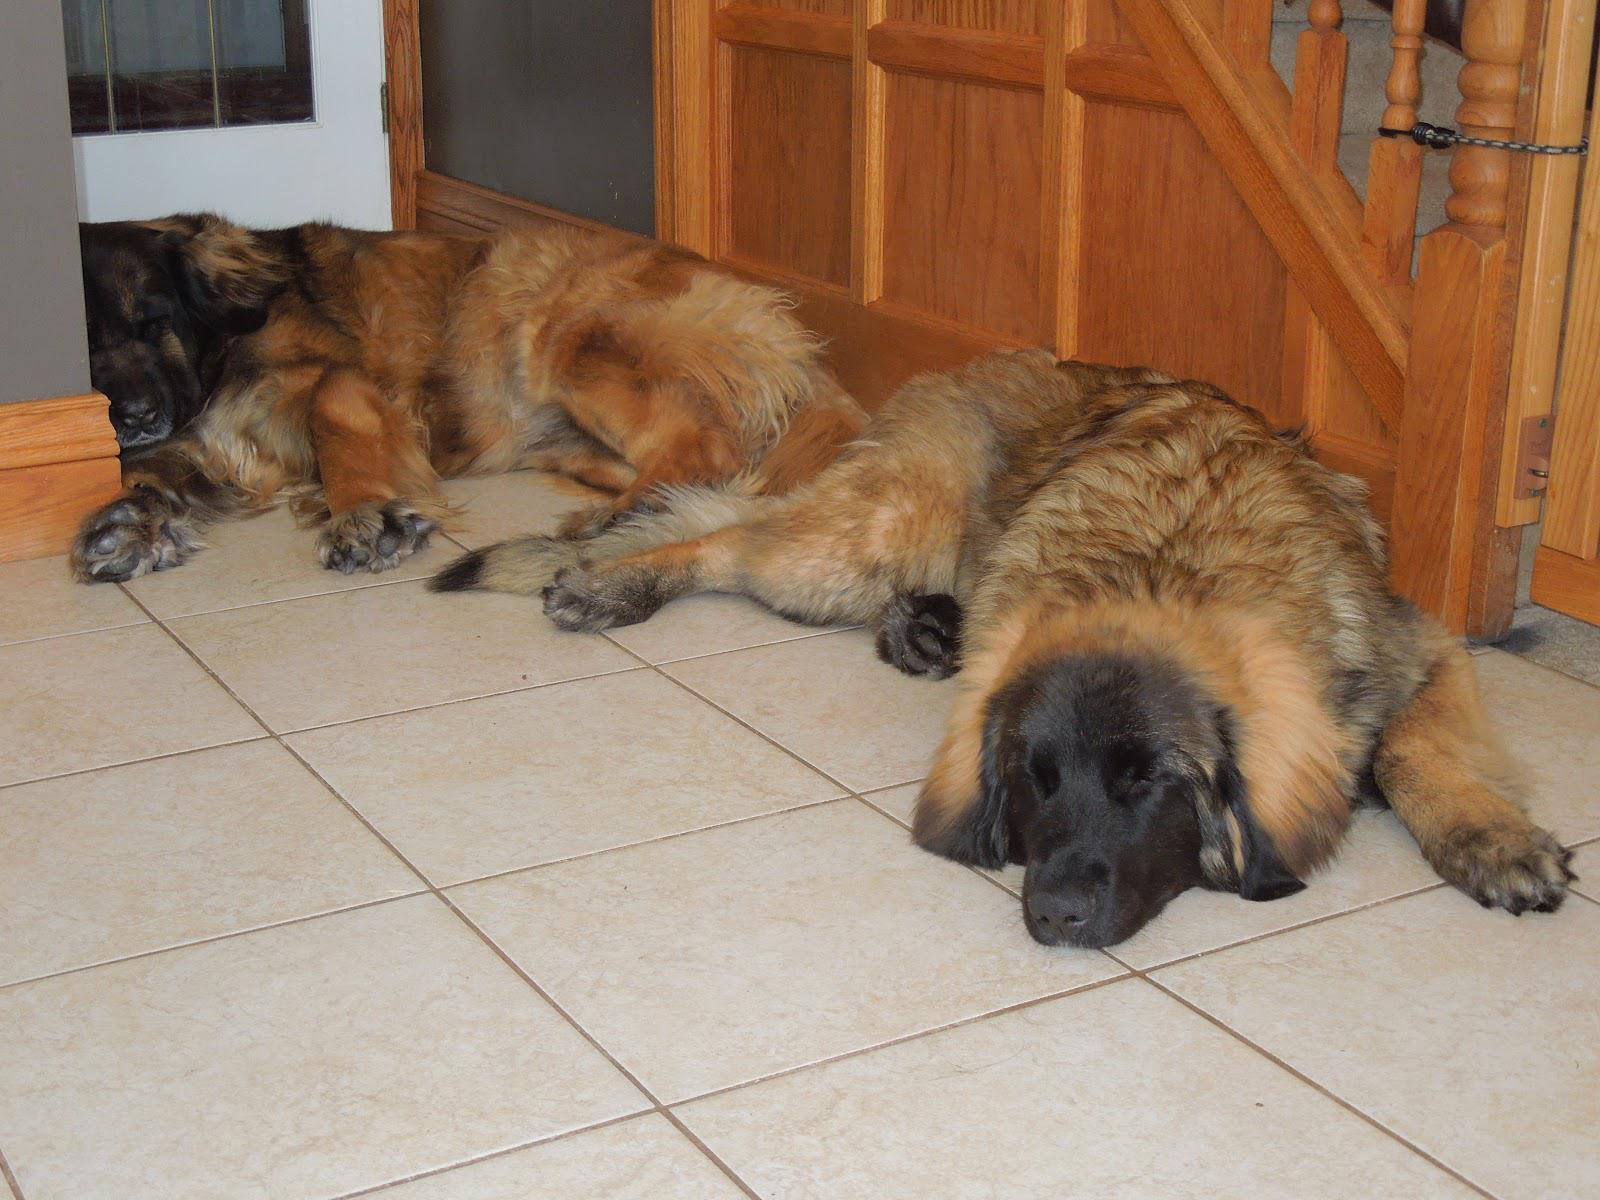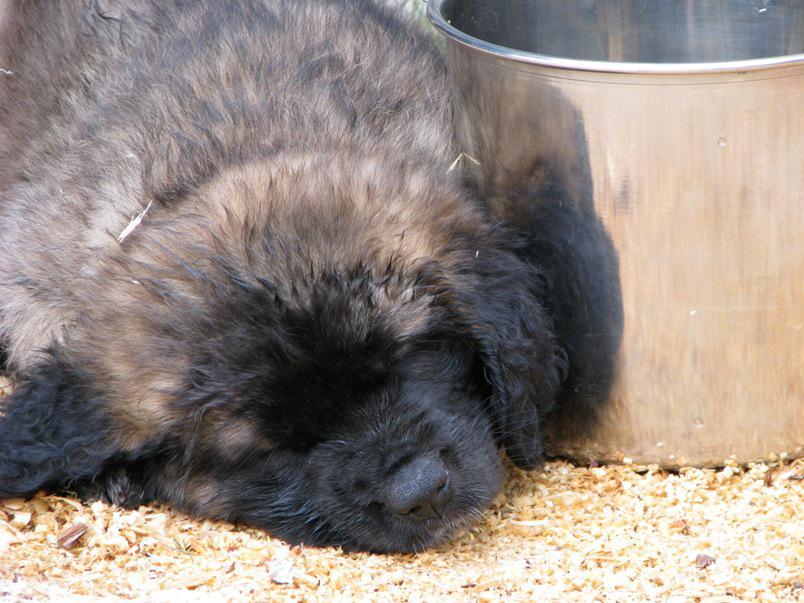The first image is the image on the left, the second image is the image on the right. Examine the images to the left and right. Is the description "All the dogs are asleep." accurate? Answer yes or no. Yes. The first image is the image on the left, the second image is the image on the right. Evaluate the accuracy of this statement regarding the images: "The dog in the left image is awake and alert.". Is it true? Answer yes or no. No. 